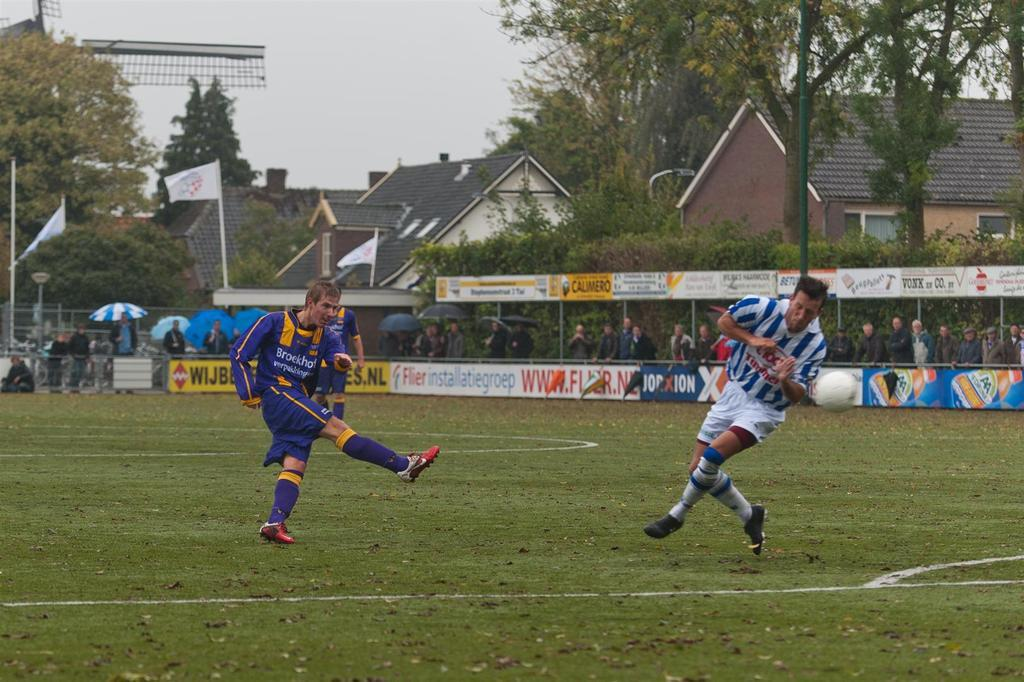<image>
Provide a brief description of the given image. Two young men go head to head in a youth soccer game. 